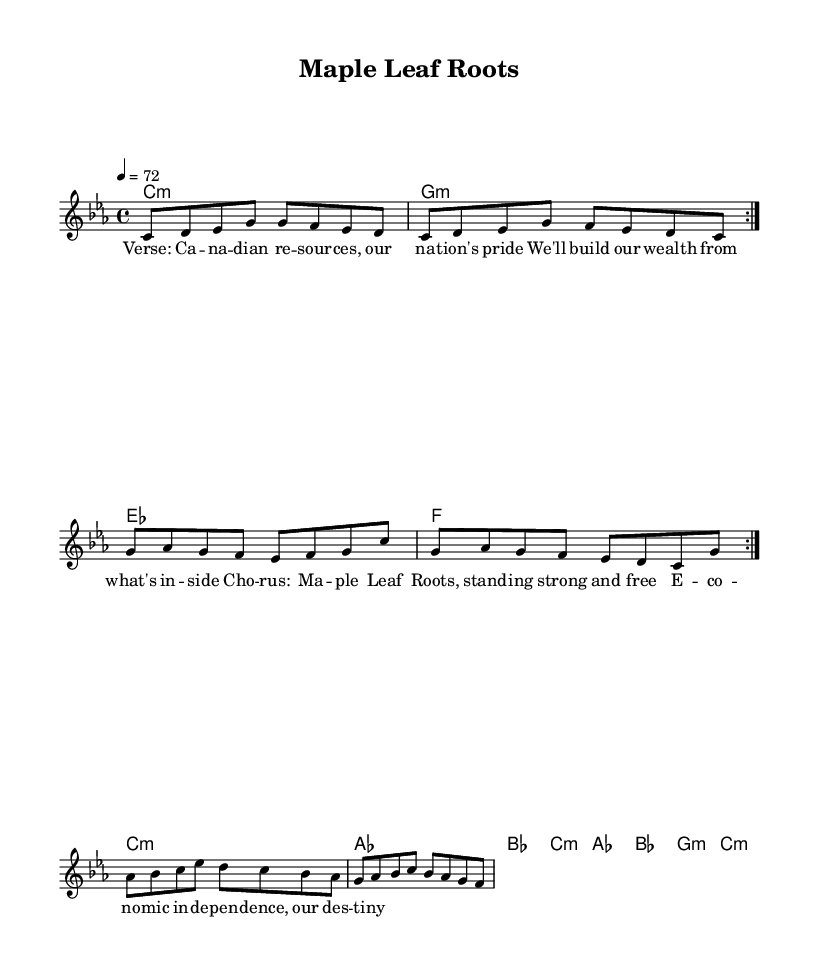What is the key signature of this music? The key signature indicates that the piece is in C minor, which has three flats: B, E, and A. This can be identified by looking at the key signature indicated at the beginning of the staff.
Answer: C minor What is the time signature of this music? The time signature is specified at the beginning of the music sheet, appearing as 4/4. This means there are four beats in each measure and the quarter note gets one beat.
Answer: 4/4 What is the tempo marking for this piece? The tempo is marked as 4 = 72, which indicates that there are 72 quarter note beats per minute. This tempo marking is typically found at the start of the score.
Answer: 72 How many measures are in the melody? By counting the distinct groups of notes separated by vertical lines (bars), there are a total of 8 measures in the melody section, divided into two repeat sections of 4 measures each.
Answer: 8 What is the primary lyrical theme of the song? The lyrics indicate a focus on Canadian resources and economic independence, as presented in the verse. The lyrics emphasize building wealth based on internal resources.
Answer: Economic independence How does the chord progression support the song's theme? The chord progression alternates between minor and major chords, creating an uplifting yet reflective mood that supports the theme of striving for independence and strength. The use of minor chords particularly adds depth and resonance to the expressions of struggle and triumph.
Answer: Alternating minor and major chords What aspect of reggae is reflected in this music piece? The music reflects the reggae genre's characteristic rhythm and emphasis on social themes, especially in terms of economic self-reliance and empowerment. These themes are prominent in the lyrics and the overall feel of the song.
Answer: Social themes and economic self-reliance 